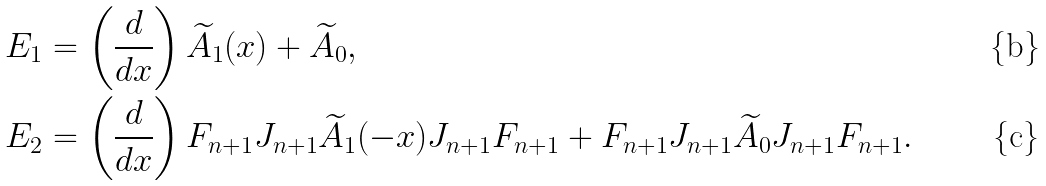<formula> <loc_0><loc_0><loc_500><loc_500>E _ { 1 } & = \left ( \frac { d } { d x } \right ) \widetilde { A } _ { 1 } ( x ) + \widetilde { A } _ { 0 } , \\ E _ { 2 } & = \left ( \frac { d } { d x } \right ) F _ { n + 1 } J _ { n + 1 } \widetilde { A } _ { 1 } ( - x ) J _ { n + 1 } F _ { n + 1 } + F _ { n + 1 } J _ { n + 1 } \widetilde { A } _ { 0 } J _ { n + 1 } F _ { n + 1 } .</formula> 